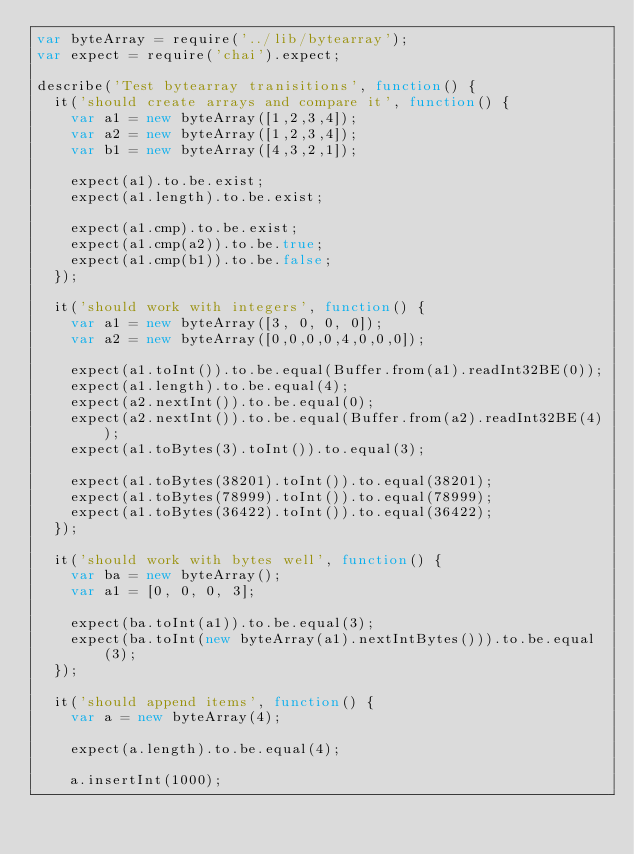Convert code to text. <code><loc_0><loc_0><loc_500><loc_500><_JavaScript_>var byteArray = require('../lib/bytearray');
var expect = require('chai').expect;

describe('Test bytearray tranisitions', function() {
  it('should create arrays and compare it', function() {
    var a1 = new byteArray([1,2,3,4]);
    var a2 = new byteArray([1,2,3,4]);
    var b1 = new byteArray([4,3,2,1]);

    expect(a1).to.be.exist;
    expect(a1.length).to.be.exist;

    expect(a1.cmp).to.be.exist;
    expect(a1.cmp(a2)).to.be.true;
    expect(a1.cmp(b1)).to.be.false;
  });

  it('should work with integers', function() {
    var a1 = new byteArray([3, 0, 0, 0]);
    var a2 = new byteArray([0,0,0,0,4,0,0,0]);

    expect(a1.toInt()).to.be.equal(Buffer.from(a1).readInt32BE(0));
    expect(a1.length).to.be.equal(4);
    expect(a2.nextInt()).to.be.equal(0);
    expect(a2.nextInt()).to.be.equal(Buffer.from(a2).readInt32BE(4));
    expect(a1.toBytes(3).toInt()).to.equal(3);

    expect(a1.toBytes(38201).toInt()).to.equal(38201);
    expect(a1.toBytes(78999).toInt()).to.equal(78999);
    expect(a1.toBytes(36422).toInt()).to.equal(36422);
  });

  it('should work with bytes well', function() {
    var ba = new byteArray();
    var a1 = [0, 0, 0, 3];

    expect(ba.toInt(a1)).to.be.equal(3);
    expect(ba.toInt(new byteArray(a1).nextIntBytes())).to.be.equal(3);
  });

  it('should append items', function() {
    var a = new byteArray(4);

    expect(a.length).to.be.equal(4);

    a.insertInt(1000);
</code> 